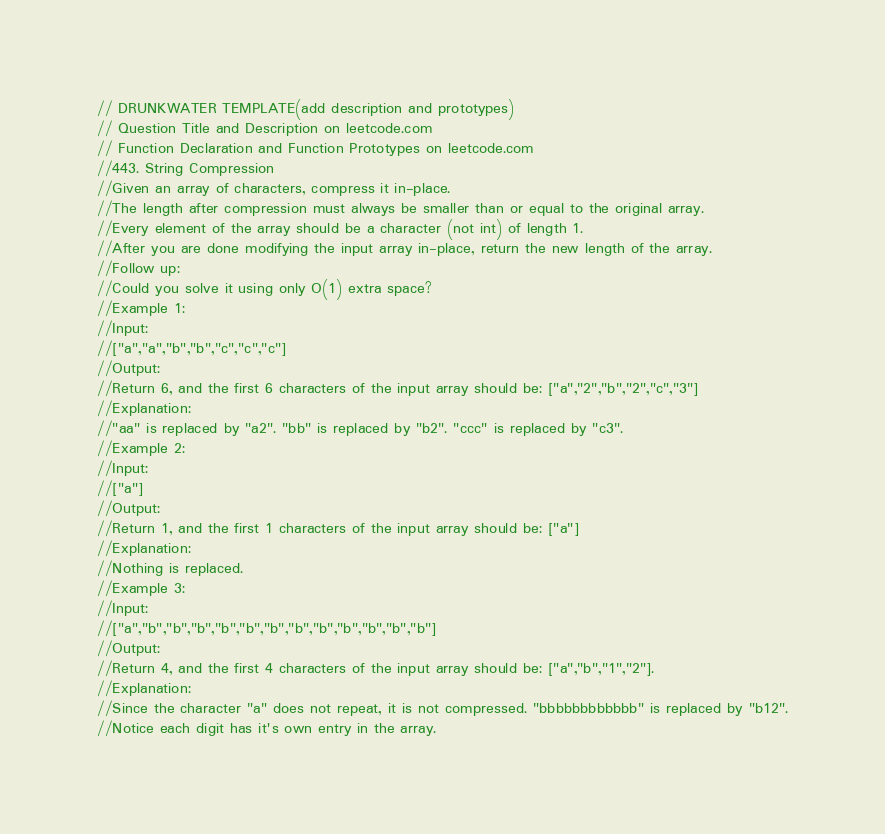<code> <loc_0><loc_0><loc_500><loc_500><_C++_>// DRUNKWATER TEMPLATE(add description and prototypes)
// Question Title and Description on leetcode.com
// Function Declaration and Function Prototypes on leetcode.com
//443. String Compression
//Given an array of characters, compress it in-place.
//The length after compression must always be smaller than or equal to the original array.
//Every element of the array should be a character (not int) of length 1.
//After you are done modifying the input array in-place, return the new length of the array.
//Follow up:
//Could you solve it using only O(1) extra space?
//Example 1:
//Input:
//["a","a","b","b","c","c","c"]
//Output:
//Return 6, and the first 6 characters of the input array should be: ["a","2","b","2","c","3"]
//Explanation:
//"aa" is replaced by "a2". "bb" is replaced by "b2". "ccc" is replaced by "c3".
//Example 2:
//Input:
//["a"]
//Output:
//Return 1, and the first 1 characters of the input array should be: ["a"]
//Explanation:
//Nothing is replaced.
//Example 3:
//Input:
//["a","b","b","b","b","b","b","b","b","b","b","b","b"]
//Output:
//Return 4, and the first 4 characters of the input array should be: ["a","b","1","2"].
//Explanation:
//Since the character "a" does not repeat, it is not compressed. "bbbbbbbbbbbb" is replaced by "b12".
//Notice each digit has it's own entry in the array.</code> 